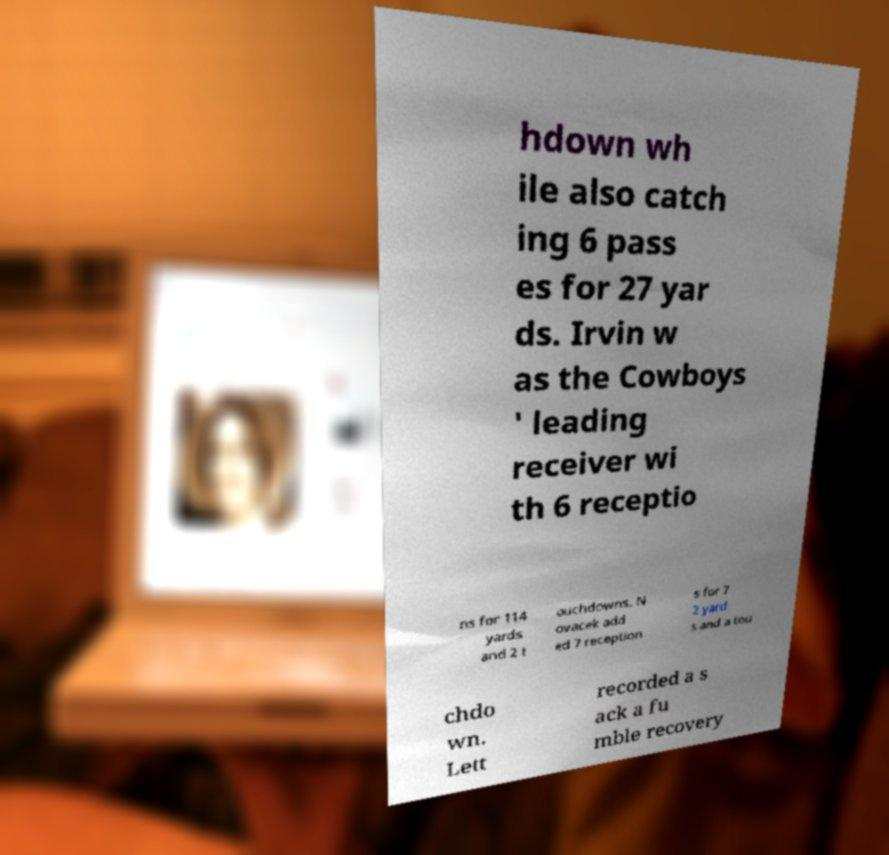I need the written content from this picture converted into text. Can you do that? hdown wh ile also catch ing 6 pass es for 27 yar ds. Irvin w as the Cowboys ' leading receiver wi th 6 receptio ns for 114 yards and 2 t ouchdowns. N ovacek add ed 7 reception s for 7 2 yard s and a tou chdo wn. Lett recorded a s ack a fu mble recovery 